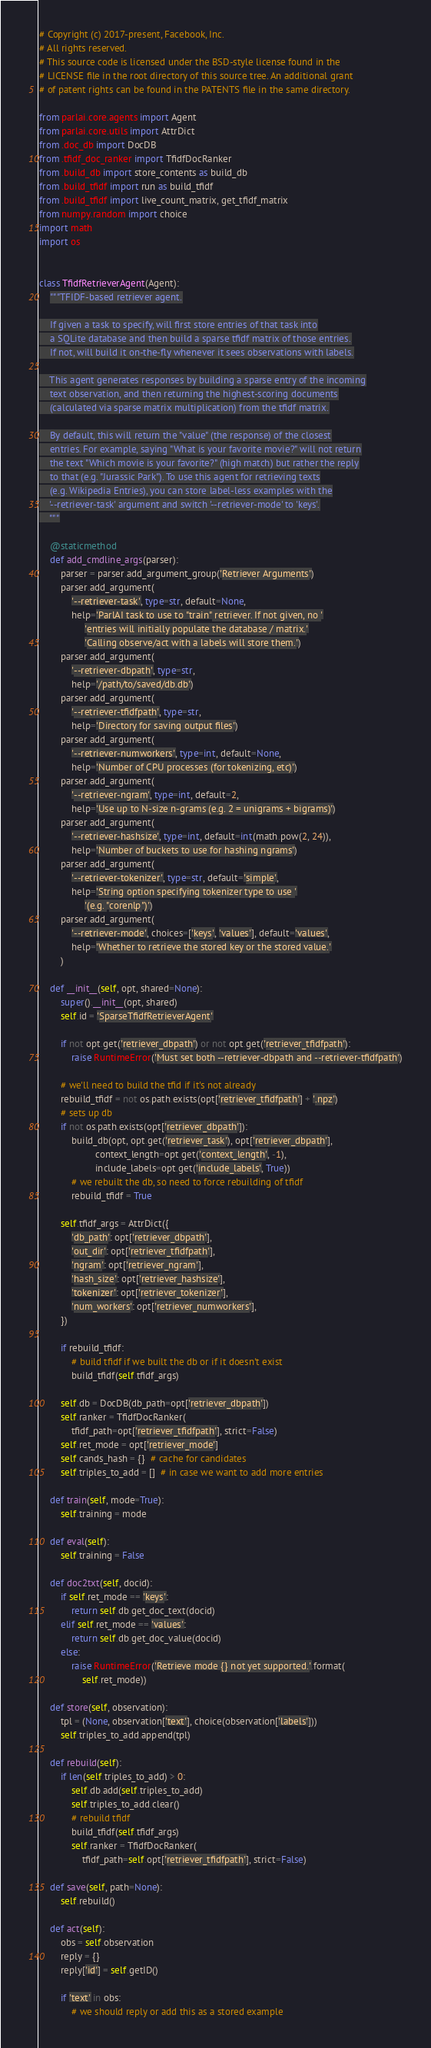Convert code to text. <code><loc_0><loc_0><loc_500><loc_500><_Python_># Copyright (c) 2017-present, Facebook, Inc.
# All rights reserved.
# This source code is licensed under the BSD-style license found in the
# LICENSE file in the root directory of this source tree. An additional grant
# of patent rights can be found in the PATENTS file in the same directory.

from parlai.core.agents import Agent
from parlai.core.utils import AttrDict
from .doc_db import DocDB
from .tfidf_doc_ranker import TfidfDocRanker
from .build_db import store_contents as build_db
from .build_tfidf import run as build_tfidf
from .build_tfidf import live_count_matrix, get_tfidf_matrix
from numpy.random import choice
import math
import os


class TfidfRetrieverAgent(Agent):
    """TFIDF-based retriever agent.

    If given a task to specify, will first store entries of that task into
    a SQLite database and then build a sparse tfidf matrix of those entries.
    If not, will build it on-the-fly whenever it sees observations with labels.

    This agent generates responses by building a sparse entry of the incoming
    text observation, and then returning the highest-scoring documents
    (calculated via sparse matrix multiplication) from the tfidf matrix.

    By default, this will return the "value" (the response) of the closest
    entries. For example, saying "What is your favorite movie?" will not return
    the text "Which movie is your favorite?" (high match) but rather the reply
    to that (e.g. "Jurassic Park"). To use this agent for retrieving texts
    (e.g. Wikipedia Entries), you can store label-less examples with the
    '--retriever-task' argument and switch '--retriever-mode' to 'keys'.
    """

    @staticmethod
    def add_cmdline_args(parser):
        parser = parser.add_argument_group('Retriever Arguments')
        parser.add_argument(
            '--retriever-task', type=str, default=None,
            help='ParlAI task to use to "train" retriever. If not given, no '
                 'entries will initially populate the database / matrix.'
                 'Calling observe/act with a labels will store them.')
        parser.add_argument(
            '--retriever-dbpath', type=str,
            help='/path/to/saved/db.db')
        parser.add_argument(
            '--retriever-tfidfpath', type=str,
            help='Directory for saving output files')
        parser.add_argument(
            '--retriever-numworkers', type=int, default=None,
            help='Number of CPU processes (for tokenizing, etc)')
        parser.add_argument(
            '--retriever-ngram', type=int, default=2,
            help='Use up to N-size n-grams (e.g. 2 = unigrams + bigrams)')
        parser.add_argument(
            '--retriever-hashsize', type=int, default=int(math.pow(2, 24)),
            help='Number of buckets to use for hashing ngrams')
        parser.add_argument(
            '--retriever-tokenizer', type=str, default='simple',
            help='String option specifying tokenizer type to use '
                 '(e.g. "corenlp")')
        parser.add_argument(
            '--retriever-mode', choices=['keys', 'values'], default='values',
            help='Whether to retrieve the stored key or the stored value.'
        )

    def __init__(self, opt, shared=None):
        super().__init__(opt, shared)
        self.id = 'SparseTfidfRetrieverAgent'

        if not opt.get('retriever_dbpath') or not opt.get('retriever_tfidfpath'):
            raise RuntimeError('Must set both --retriever-dbpath and --retriever-tfidfpath')

        # we'll need to build the tfid if it's not already
        rebuild_tfidf = not os.path.exists(opt['retriever_tfidfpath'] + '.npz')
        # sets up db
        if not os.path.exists(opt['retriever_dbpath']):
            build_db(opt, opt.get('retriever_task'), opt['retriever_dbpath'],
                     context_length=opt.get('context_length', -1),
                     include_labels=opt.get('include_labels', True))
            # we rebuilt the db, so need to force rebuilding of tfidf
            rebuild_tfidf = True

        self.tfidf_args = AttrDict({
            'db_path': opt['retriever_dbpath'],
            'out_dir': opt['retriever_tfidfpath'],
            'ngram': opt['retriever_ngram'],
            'hash_size': opt['retriever_hashsize'],
            'tokenizer': opt['retriever_tokenizer'],
            'num_workers': opt['retriever_numworkers'],
        })

        if rebuild_tfidf:
            # build tfidf if we built the db or if it doesn't exist
            build_tfidf(self.tfidf_args)

        self.db = DocDB(db_path=opt['retriever_dbpath'])
        self.ranker = TfidfDocRanker(
            tfidf_path=opt['retriever_tfidfpath'], strict=False)
        self.ret_mode = opt['retriever_mode']
        self.cands_hash = {}  # cache for candidates
        self.triples_to_add = []  # in case we want to add more entries

    def train(self, mode=True):
        self.training = mode

    def eval(self):
        self.training = False

    def doc2txt(self, docid):
        if self.ret_mode == 'keys':
            return self.db.get_doc_text(docid)
        elif self.ret_mode == 'values':
            return self.db.get_doc_value(docid)
        else:
            raise RuntimeError('Retrieve mode {} not yet supported.'.format(
                self.ret_mode))

    def store(self, observation):
        tpl = (None, observation['text'], choice(observation['labels']))
        self.triples_to_add.append(tpl)

    def rebuild(self):
        if len(self.triples_to_add) > 0:
            self.db.add(self.triples_to_add)
            self.triples_to_add.clear()
            # rebuild tfidf
            build_tfidf(self.tfidf_args)
            self.ranker = TfidfDocRanker(
                tfidf_path=self.opt['retriever_tfidfpath'], strict=False)

    def save(self, path=None):
        self.rebuild()

    def act(self):
        obs = self.observation
        reply = {}
        reply['id'] = self.getID()

        if 'text' in obs:
            # we should reply or add this as a stored example</code> 